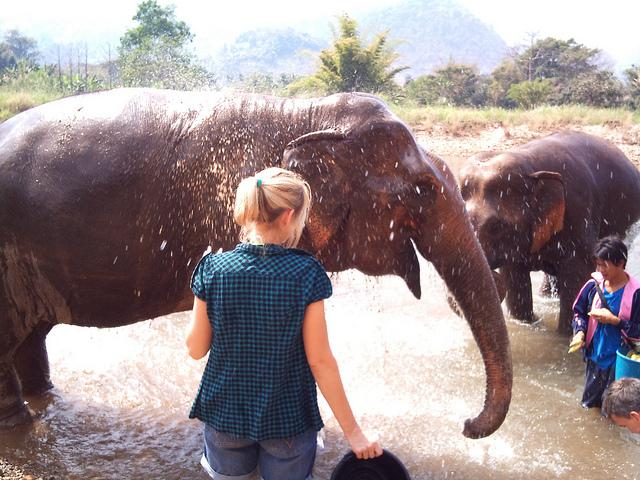Which part of the Elephant's body work to cool their body?

Choices:
A) leg
B) trunk
C) ear
D) skin trunk 